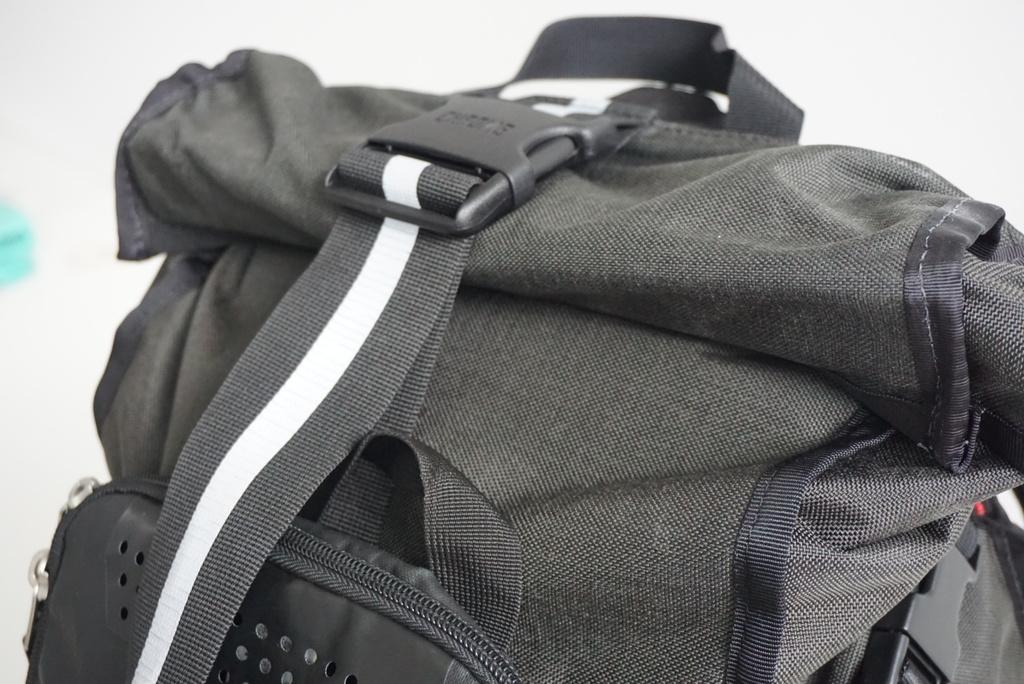What type of bag is visible in the image? There is a trekking bag in the image. What color is the trekking bag? The trekking bag is green. Who is the writer of the process described in the image? There is no process or writer mentioned in the image; it only features a green trekking bag. 